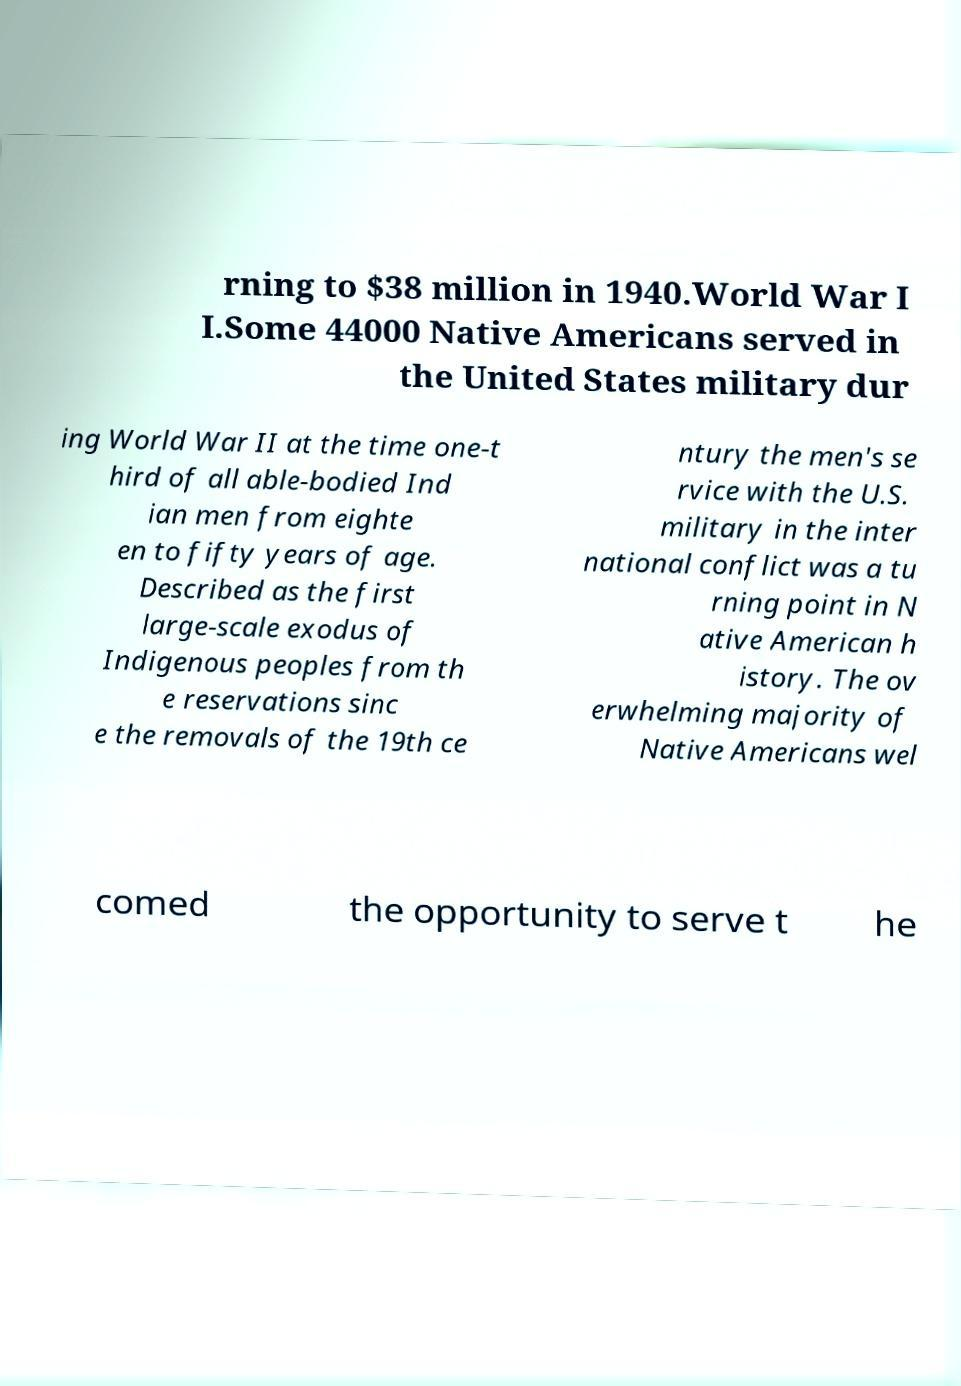What messages or text are displayed in this image? I need them in a readable, typed format. rning to $38 million in 1940.World War I I.Some 44000 Native Americans served in the United States military dur ing World War II at the time one-t hird of all able-bodied Ind ian men from eighte en to fifty years of age. Described as the first large-scale exodus of Indigenous peoples from th e reservations sinc e the removals of the 19th ce ntury the men's se rvice with the U.S. military in the inter national conflict was a tu rning point in N ative American h istory. The ov erwhelming majority of Native Americans wel comed the opportunity to serve t he 